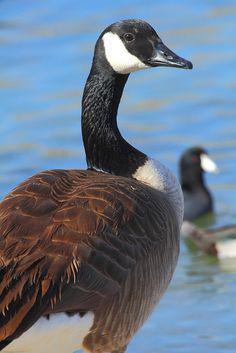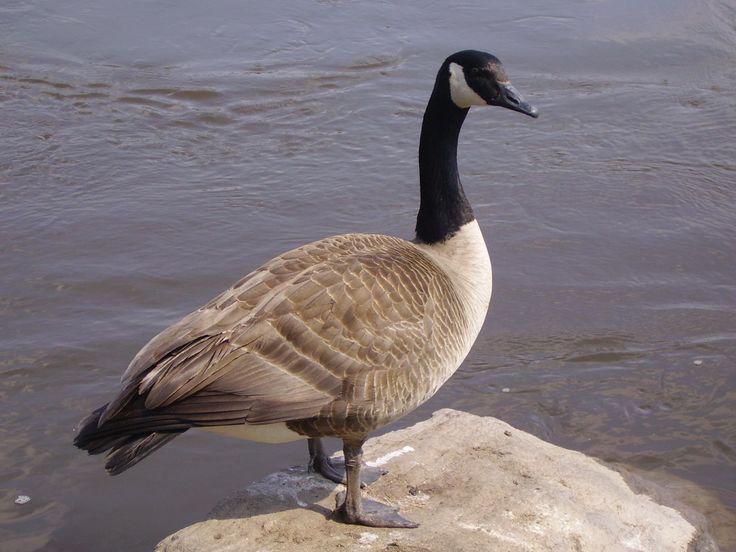The first image is the image on the left, the second image is the image on the right. Considering the images on both sides, is "More water fowl are shown in the right image." valid? Answer yes or no. No. 